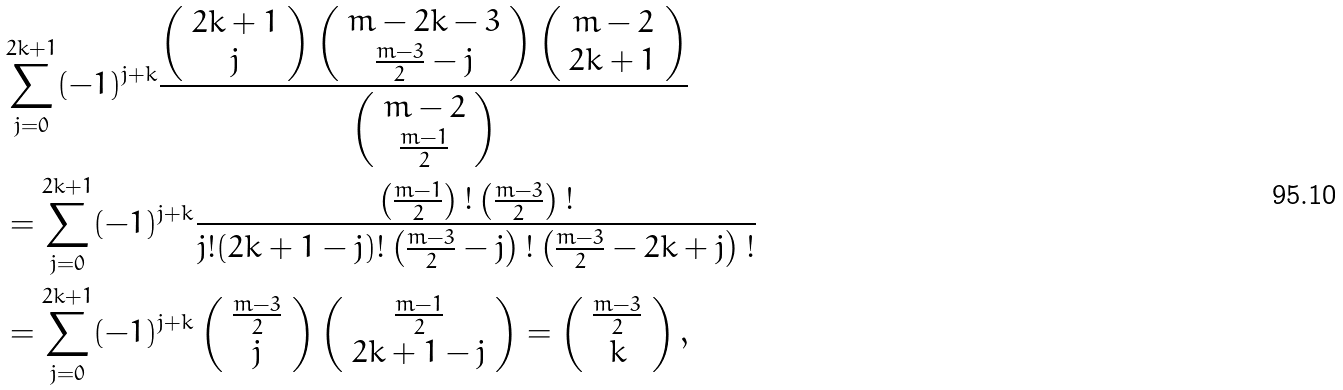Convert formula to latex. <formula><loc_0><loc_0><loc_500><loc_500>& \sum _ { j = 0 } ^ { 2 k + 1 } ( - 1 ) ^ { j + k } \frac { \left ( \begin{array} { c } 2 k + 1 \\ j \end{array} \right ) \left ( \begin{array} { c } m - 2 k - 3 \\ \frac { m - 3 } { 2 } - j \end{array} \right ) \left ( \begin{array} { c } m - 2 \\ 2 k + 1 \end{array} \right ) } { \left ( \begin{array} { c } m - 2 \\ \frac { m - 1 } { 2 } \end{array} \right ) } \\ & = \sum _ { j = 0 } ^ { 2 k + 1 } ( - 1 ) ^ { j + k } \frac { \left ( \frac { m - 1 } { 2 } \right ) ! \left ( \frac { m - 3 } { 2 } \right ) ! } { j ! ( 2 k + 1 - j ) ! \left ( \frac { m - 3 } { 2 } - j \right ) ! \left ( \frac { m - 3 } { 2 } - 2 k + j \right ) ! } \\ & = \sum _ { j = 0 } ^ { 2 k + 1 } ( - 1 ) ^ { j + k } \left ( \begin{array} { c } \frac { m - 3 } { 2 } \\ j \end{array} \right ) \left ( \begin{array} { c } \frac { m - 1 } { 2 } \\ 2 k + 1 - j \end{array} \right ) = \left ( \begin{array} { c } \frac { m - 3 } { 2 } \\ k \end{array} \right ) ,</formula> 